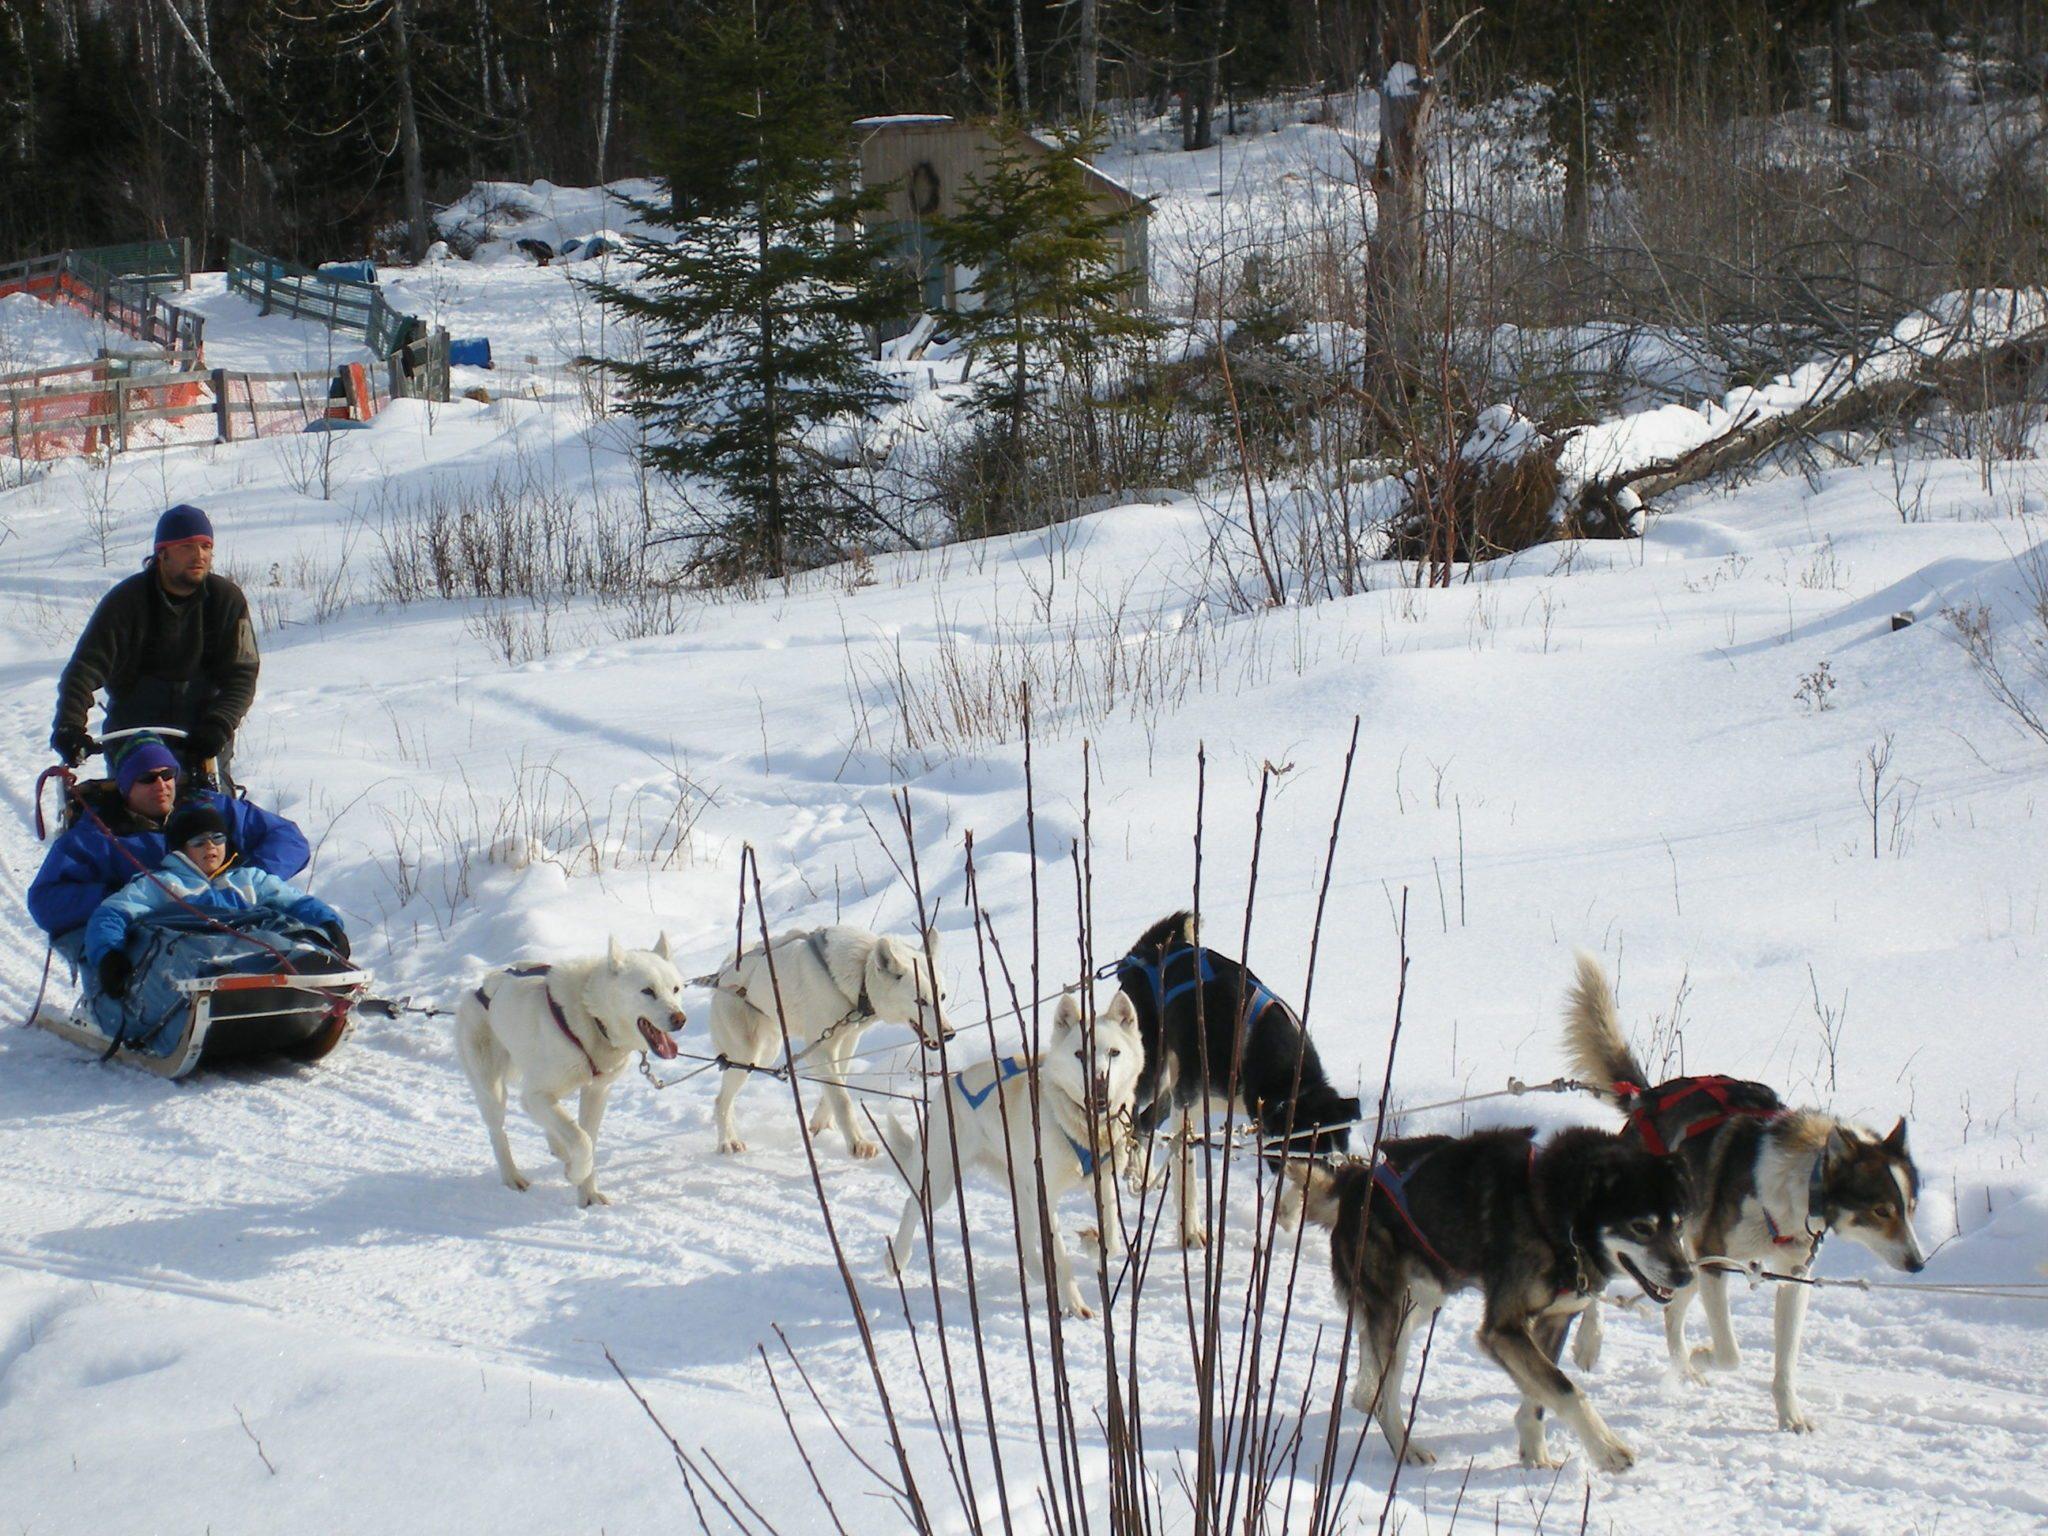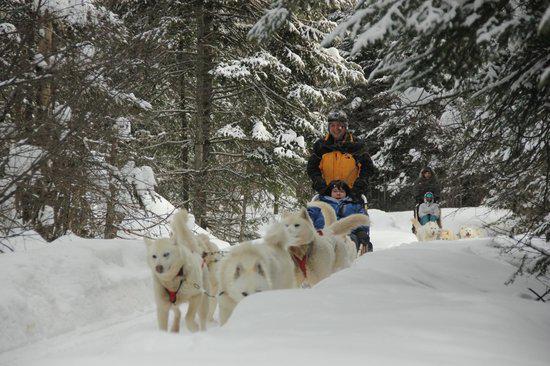The first image is the image on the left, the second image is the image on the right. Examine the images to the left and right. Is the description "A dog team led by two dark dogs is racing rightward and pulling a sled with at least one passenger." accurate? Answer yes or no. Yes. 